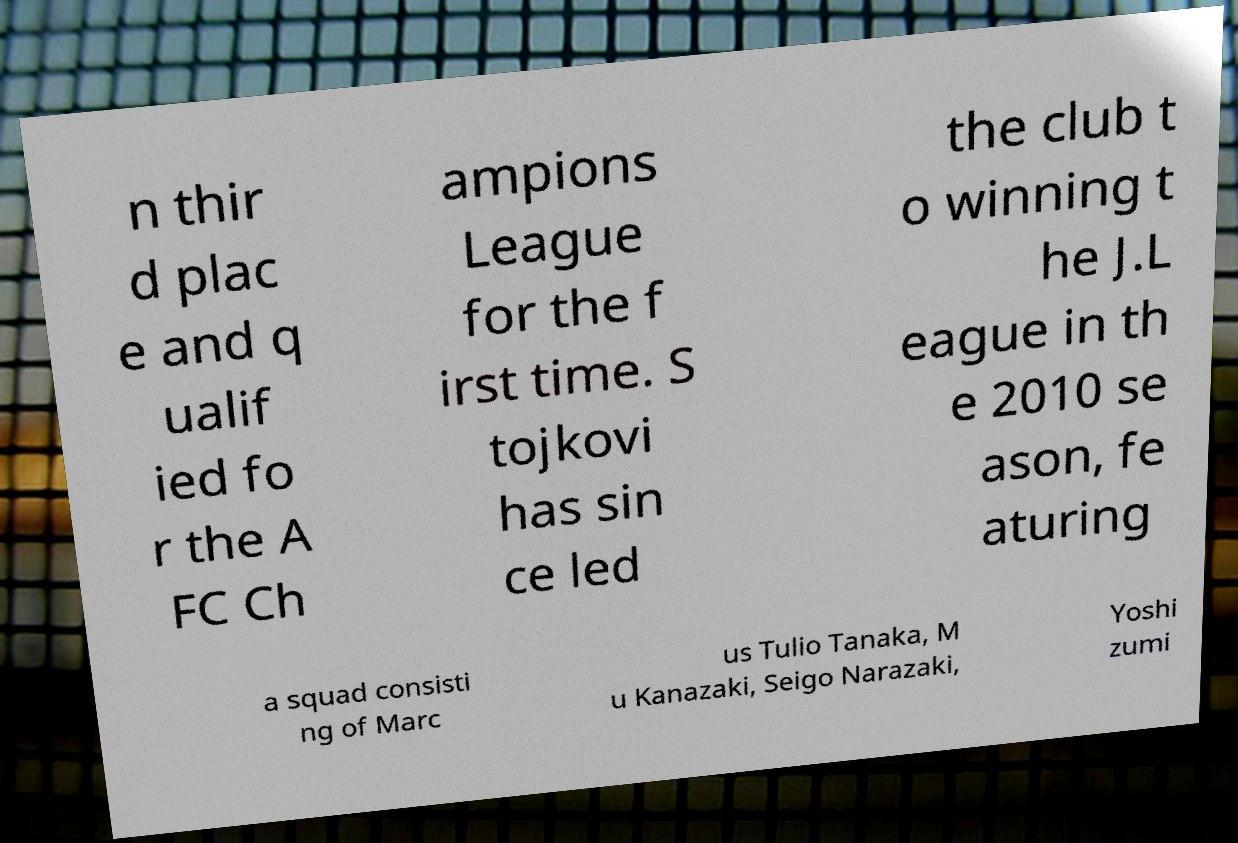What messages or text are displayed in this image? I need them in a readable, typed format. n thir d plac e and q ualif ied fo r the A FC Ch ampions League for the f irst time. S tojkovi has sin ce led the club t o winning t he J.L eague in th e 2010 se ason, fe aturing a squad consisti ng of Marc us Tulio Tanaka, M u Kanazaki, Seigo Narazaki, Yoshi zumi 